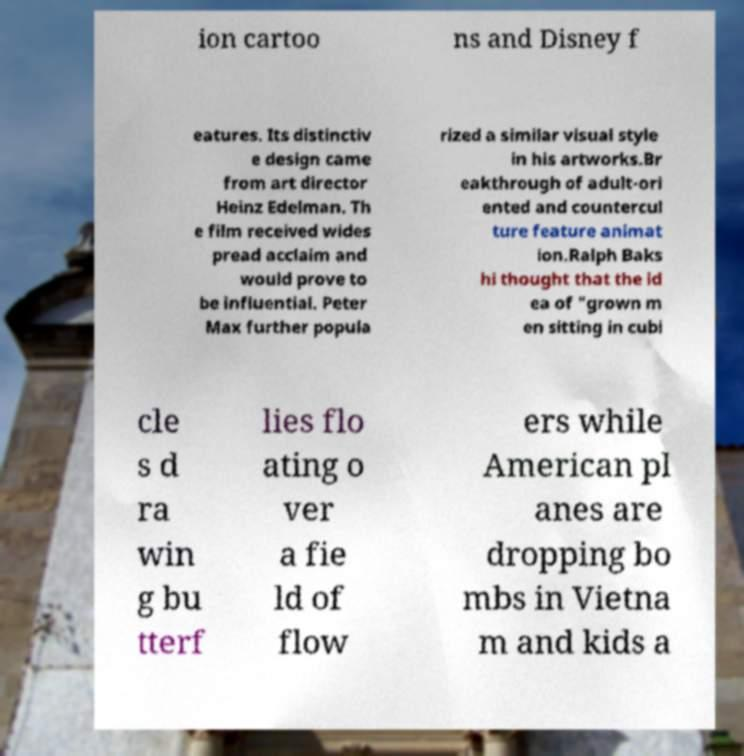Please identify and transcribe the text found in this image. ion cartoo ns and Disney f eatures. Its distinctiv e design came from art director Heinz Edelman. Th e film received wides pread acclaim and would prove to be influential. Peter Max further popula rized a similar visual style in his artworks.Br eakthrough of adult-ori ented and countercul ture feature animat ion.Ralph Baks hi thought that the id ea of "grown m en sitting in cubi cle s d ra win g bu tterf lies flo ating o ver a fie ld of flow ers while American pl anes are dropping bo mbs in Vietna m and kids a 